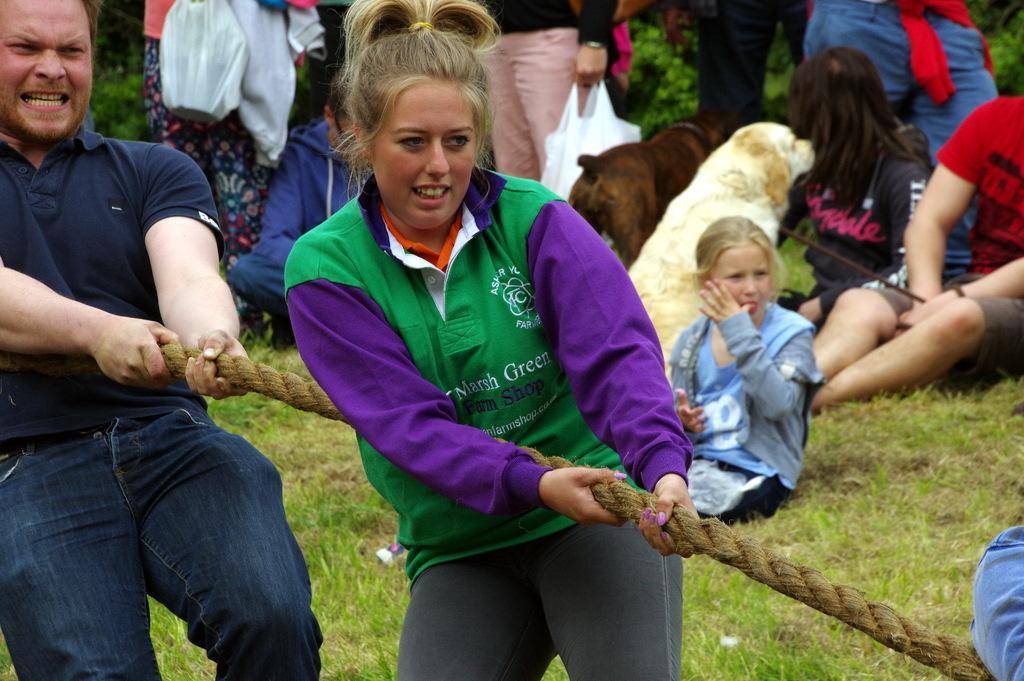How would you summarize this image in a sentence or two? In this image I can observe a man and a woman pulling a rope. In the background there are some people. 